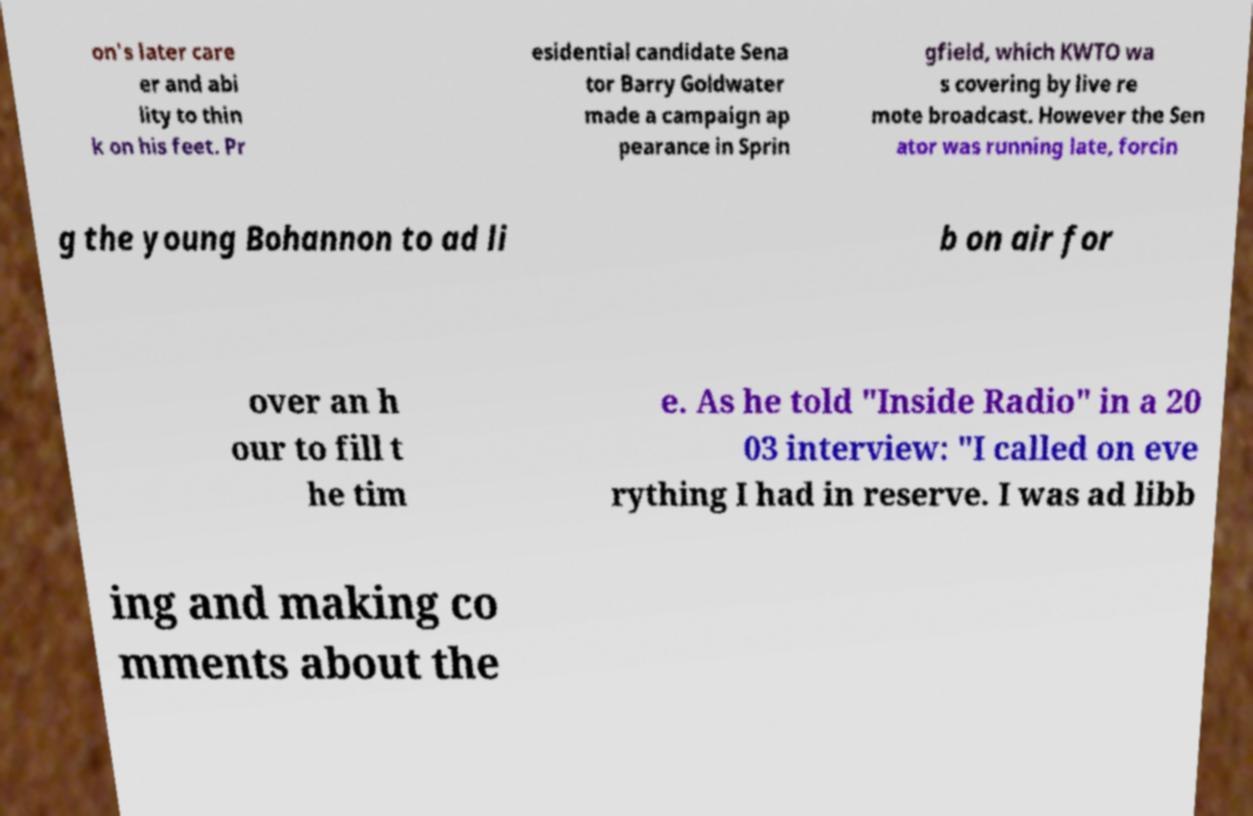Could you assist in decoding the text presented in this image and type it out clearly? on's later care er and abi lity to thin k on his feet. Pr esidential candidate Sena tor Barry Goldwater made a campaign ap pearance in Sprin gfield, which KWTO wa s covering by live re mote broadcast. However the Sen ator was running late, forcin g the young Bohannon to ad li b on air for over an h our to fill t he tim e. As he told "Inside Radio" in a 20 03 interview: "I called on eve rything I had in reserve. I was ad libb ing and making co mments about the 